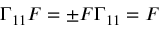<formula> <loc_0><loc_0><loc_500><loc_500>\Gamma _ { 1 1 } F = \pm F \Gamma _ { 1 1 } = F</formula> 